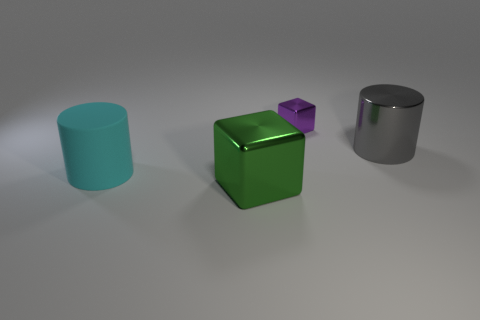There is another thing that is the same shape as the tiny purple object; what material is it?
Offer a very short reply. Metal. Are there fewer big cyan things than large red matte objects?
Keep it short and to the point. No. Is the tiny thing made of the same material as the gray object?
Your response must be concise. Yes. What number of other objects are there of the same color as the small shiny cube?
Your answer should be compact. 0. Is the number of purple shiny objects greater than the number of tiny green metallic cylinders?
Provide a succinct answer. Yes. Does the gray thing have the same size as the cylinder left of the green shiny cube?
Your answer should be very brief. Yes. What is the color of the large cylinder that is to the left of the small purple metallic cube?
Offer a very short reply. Cyan. How many green things are tiny blocks or big objects?
Offer a terse response. 1. What is the color of the matte object?
Make the answer very short. Cyan. Are there any other things that have the same material as the green thing?
Give a very brief answer. Yes. 